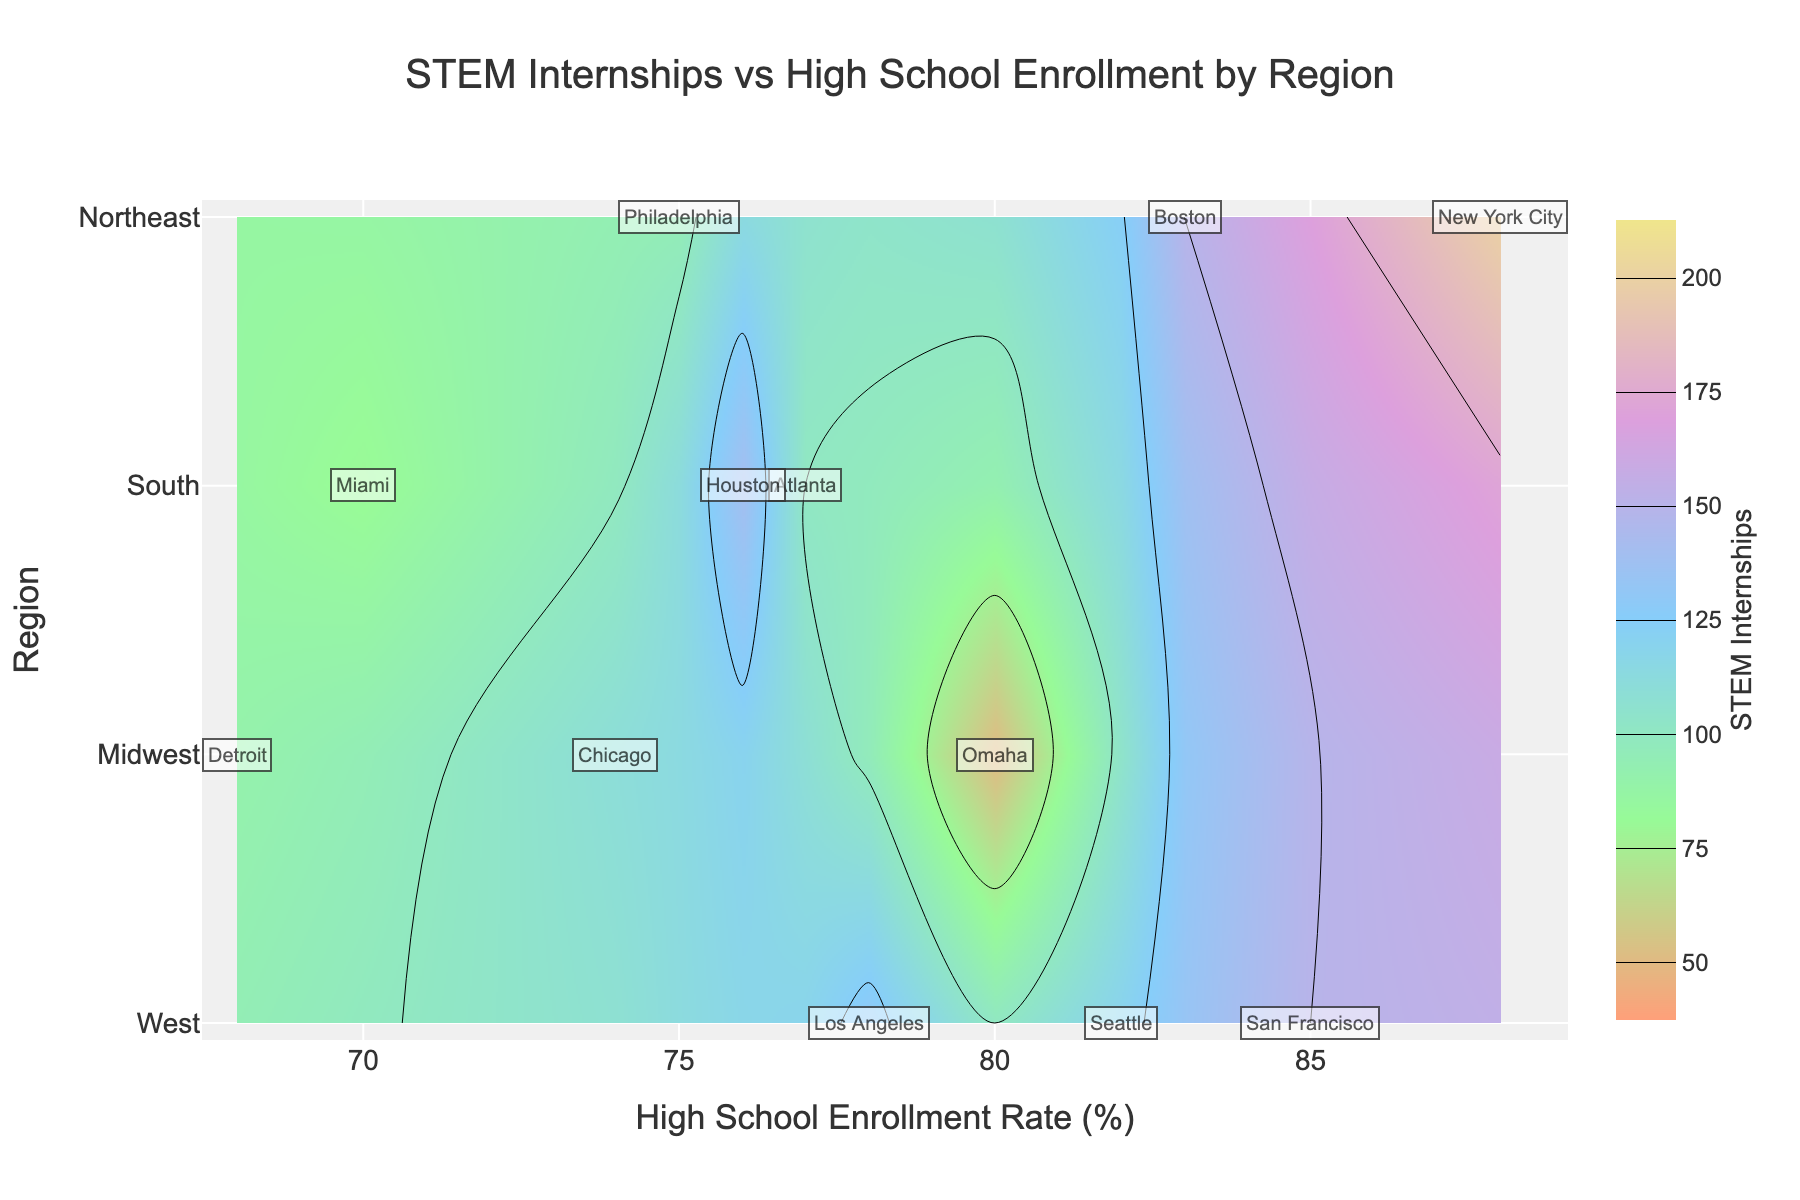What is the title of the figure? The title is usually placed at the top center of the figure. In this case, it reads, "STEM Internships vs High School Enrollment by Region".
Answer: STEM Internships vs High School Enrollment by Region How many regions are represented in the plot? The regions are shown on the y-axis, and each unique label represents a different region. The plot includes the labels: West, Midwest, South, and Northeast.
Answer: 4 Which region has the highest number of STEM internship opportunities? Hover over different parts of the plot to see the number of STEM internship opportunities for each region. The region with the highest value is the Northeast with 200 opportunities in New York City.
Answer: Northeast What is the average number of STEM internship opportunities for the Midwest region? To find the average, first identify the number of internships in the Midwest cities: Chicago (110), Detroit (90), and Omaha (50). Sum them up (110 + 90 + 50 = 250) and divide by the number of cities (3).
Answer: (110 + 90 + 50) / 3 = 83.33, so 83.33 Which city has the highest high school enrollment rate? Look for the highest value on the x-axis (Enrollment Rate) and see the city annotated at that point. The highest value is 88%, annotated as New York City.
Answer: New York City Compare the number of STEM internship opportunities between Los Angeles and Houston. Which city has more? Hover over the plot data points corresponding to Los Angeles and Houston. Los Angeles has 130 opportunities, and Houston has 140. Houston has more.
Answer: Houston How does Seattle's high school enrollment rate compare to Omaha's? Check the x-axis values for Seattle and Omaha. Seattle has an enrollment rate of 82%, whereas Omaha has 80%. Seattle's enrollment rate is higher.
Answer: Seattle's rate is higher What's the difference in the number of STEM internship opportunities between Boston and Philadelphia? Check the plot's hover data for Boston and Philadelphia. Boston has 150 opportunities, and Philadelphia has 95. The difference is 150 - 95.
Answer: 55 Which region has the lowest number of STEM internship opportunities, and what is the value? Hover over various regions to check their STEM internship opportunities. The region with the lowest value on the contour plot is the Midwest, specifically in Omaha, with 50 opportunities.
Answer: Midwest with 50 What is the trend observed between the high school enrollment rate and the number of STEM internship opportunities? Analyze the contour lines and the plotted data points. Generally, higher high school enrollment rates correlate with higher numbers of STEM internship opportunities, but there are exceptions and variances within each region.
Answer: Positive correlation with some exceptions 